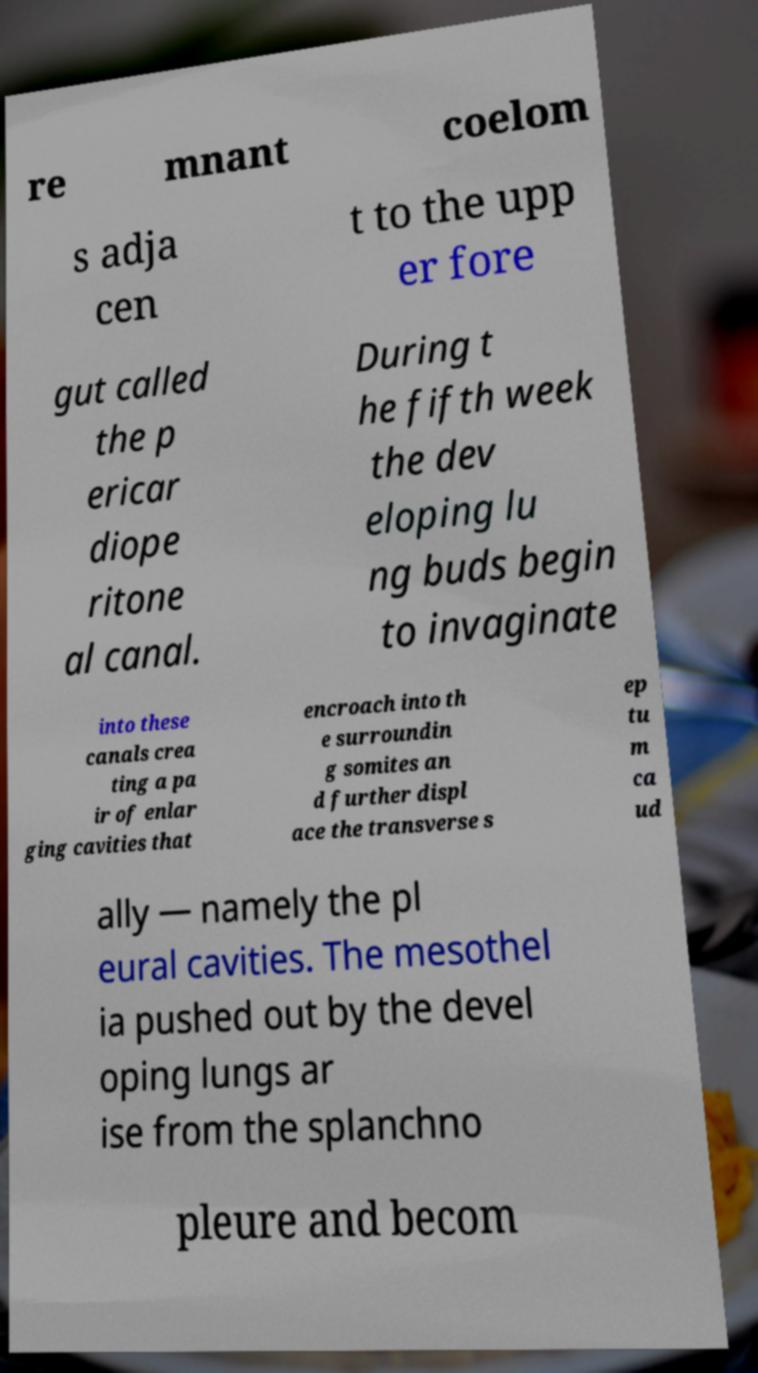For documentation purposes, I need the text within this image transcribed. Could you provide that? re mnant coelom s adja cen t to the upp er fore gut called the p ericar diope ritone al canal. During t he fifth week the dev eloping lu ng buds begin to invaginate into these canals crea ting a pa ir of enlar ging cavities that encroach into th e surroundin g somites an d further displ ace the transverse s ep tu m ca ud ally — namely the pl eural cavities. The mesothel ia pushed out by the devel oping lungs ar ise from the splanchno pleure and becom 